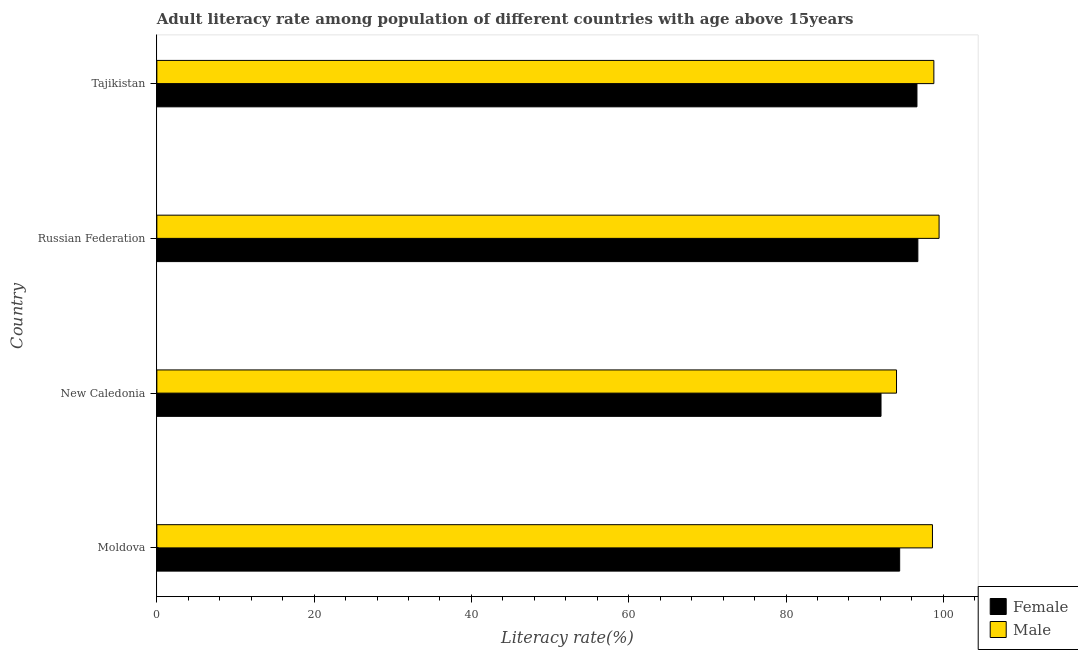How many groups of bars are there?
Provide a succinct answer. 4. Are the number of bars on each tick of the Y-axis equal?
Offer a terse response. Yes. How many bars are there on the 1st tick from the top?
Give a very brief answer. 2. What is the label of the 3rd group of bars from the top?
Offer a terse response. New Caledonia. In how many cases, is the number of bars for a given country not equal to the number of legend labels?
Keep it short and to the point. 0. What is the male adult literacy rate in New Caledonia?
Ensure brevity in your answer.  94.04. Across all countries, what is the maximum female adult literacy rate?
Your response must be concise. 96.76. Across all countries, what is the minimum male adult literacy rate?
Provide a short and direct response. 94.04. In which country was the female adult literacy rate maximum?
Offer a terse response. Russian Federation. In which country was the male adult literacy rate minimum?
Provide a succinct answer. New Caledonia. What is the total male adult literacy rate in the graph?
Your answer should be very brief. 390.91. What is the difference between the male adult literacy rate in Moldova and that in Russian Federation?
Offer a terse response. -0.84. What is the difference between the female adult literacy rate in Moldova and the male adult literacy rate in Tajikistan?
Keep it short and to the point. -4.35. What is the average male adult literacy rate per country?
Your answer should be compact. 97.73. What is the difference between the female adult literacy rate and male adult literacy rate in Russian Federation?
Ensure brevity in your answer.  -2.7. What is the ratio of the male adult literacy rate in Moldova to that in New Caledonia?
Keep it short and to the point. 1.05. What is the difference between the highest and the second highest male adult literacy rate?
Make the answer very short. 0.67. What is the difference between the highest and the lowest female adult literacy rate?
Your answer should be compact. 4.68. What does the 2nd bar from the top in Tajikistan represents?
Your answer should be compact. Female. What does the 2nd bar from the bottom in Moldova represents?
Provide a succinct answer. Male. How many bars are there?
Offer a terse response. 8. Are all the bars in the graph horizontal?
Keep it short and to the point. Yes. How many countries are there in the graph?
Offer a terse response. 4. What is the difference between two consecutive major ticks on the X-axis?
Ensure brevity in your answer.  20. Are the values on the major ticks of X-axis written in scientific E-notation?
Provide a succinct answer. No. Does the graph contain grids?
Offer a very short reply. No. Where does the legend appear in the graph?
Provide a succinct answer. Bottom right. How many legend labels are there?
Ensure brevity in your answer.  2. What is the title of the graph?
Your answer should be very brief. Adult literacy rate among population of different countries with age above 15years. Does "Transport services" appear as one of the legend labels in the graph?
Give a very brief answer. No. What is the label or title of the X-axis?
Ensure brevity in your answer.  Literacy rate(%). What is the Literacy rate(%) of Female in Moldova?
Your answer should be compact. 94.44. What is the Literacy rate(%) in Male in Moldova?
Offer a very short reply. 98.61. What is the Literacy rate(%) in Female in New Caledonia?
Your response must be concise. 92.07. What is the Literacy rate(%) of Male in New Caledonia?
Give a very brief answer. 94.04. What is the Literacy rate(%) in Female in Russian Federation?
Offer a very short reply. 96.76. What is the Literacy rate(%) of Male in Russian Federation?
Make the answer very short. 99.46. What is the Literacy rate(%) in Female in Tajikistan?
Give a very brief answer. 96.64. What is the Literacy rate(%) of Male in Tajikistan?
Your answer should be compact. 98.79. Across all countries, what is the maximum Literacy rate(%) of Female?
Keep it short and to the point. 96.76. Across all countries, what is the maximum Literacy rate(%) in Male?
Give a very brief answer. 99.46. Across all countries, what is the minimum Literacy rate(%) of Female?
Offer a very short reply. 92.07. Across all countries, what is the minimum Literacy rate(%) in Male?
Offer a very short reply. 94.04. What is the total Literacy rate(%) of Female in the graph?
Your answer should be very brief. 379.92. What is the total Literacy rate(%) of Male in the graph?
Your answer should be compact. 390.91. What is the difference between the Literacy rate(%) of Female in Moldova and that in New Caledonia?
Your answer should be compact. 2.37. What is the difference between the Literacy rate(%) of Male in Moldova and that in New Caledonia?
Offer a very short reply. 4.57. What is the difference between the Literacy rate(%) of Female in Moldova and that in Russian Federation?
Provide a succinct answer. -2.31. What is the difference between the Literacy rate(%) of Male in Moldova and that in Russian Federation?
Ensure brevity in your answer.  -0.84. What is the difference between the Literacy rate(%) in Female in Moldova and that in Tajikistan?
Ensure brevity in your answer.  -2.2. What is the difference between the Literacy rate(%) in Male in Moldova and that in Tajikistan?
Keep it short and to the point. -0.18. What is the difference between the Literacy rate(%) in Female in New Caledonia and that in Russian Federation?
Keep it short and to the point. -4.68. What is the difference between the Literacy rate(%) of Male in New Caledonia and that in Russian Federation?
Make the answer very short. -5.41. What is the difference between the Literacy rate(%) in Female in New Caledonia and that in Tajikistan?
Your answer should be very brief. -4.57. What is the difference between the Literacy rate(%) of Male in New Caledonia and that in Tajikistan?
Keep it short and to the point. -4.75. What is the difference between the Literacy rate(%) of Female in Russian Federation and that in Tajikistan?
Keep it short and to the point. 0.12. What is the difference between the Literacy rate(%) of Male in Russian Federation and that in Tajikistan?
Keep it short and to the point. 0.67. What is the difference between the Literacy rate(%) in Female in Moldova and the Literacy rate(%) in Male in New Caledonia?
Provide a succinct answer. 0.4. What is the difference between the Literacy rate(%) of Female in Moldova and the Literacy rate(%) of Male in Russian Federation?
Make the answer very short. -5.01. What is the difference between the Literacy rate(%) of Female in Moldova and the Literacy rate(%) of Male in Tajikistan?
Keep it short and to the point. -4.35. What is the difference between the Literacy rate(%) of Female in New Caledonia and the Literacy rate(%) of Male in Russian Federation?
Your response must be concise. -7.38. What is the difference between the Literacy rate(%) of Female in New Caledonia and the Literacy rate(%) of Male in Tajikistan?
Offer a very short reply. -6.72. What is the difference between the Literacy rate(%) in Female in Russian Federation and the Literacy rate(%) in Male in Tajikistan?
Keep it short and to the point. -2.03. What is the average Literacy rate(%) of Female per country?
Your response must be concise. 94.98. What is the average Literacy rate(%) in Male per country?
Ensure brevity in your answer.  97.73. What is the difference between the Literacy rate(%) in Female and Literacy rate(%) in Male in Moldova?
Your answer should be compact. -4.17. What is the difference between the Literacy rate(%) in Female and Literacy rate(%) in Male in New Caledonia?
Keep it short and to the point. -1.97. What is the difference between the Literacy rate(%) in Female and Literacy rate(%) in Male in Russian Federation?
Keep it short and to the point. -2.7. What is the difference between the Literacy rate(%) of Female and Literacy rate(%) of Male in Tajikistan?
Offer a terse response. -2.15. What is the ratio of the Literacy rate(%) in Female in Moldova to that in New Caledonia?
Provide a short and direct response. 1.03. What is the ratio of the Literacy rate(%) of Male in Moldova to that in New Caledonia?
Offer a very short reply. 1.05. What is the ratio of the Literacy rate(%) of Female in Moldova to that in Russian Federation?
Your response must be concise. 0.98. What is the ratio of the Literacy rate(%) of Male in Moldova to that in Russian Federation?
Offer a terse response. 0.99. What is the ratio of the Literacy rate(%) of Female in Moldova to that in Tajikistan?
Your answer should be compact. 0.98. What is the ratio of the Literacy rate(%) of Female in New Caledonia to that in Russian Federation?
Your response must be concise. 0.95. What is the ratio of the Literacy rate(%) in Male in New Caledonia to that in Russian Federation?
Give a very brief answer. 0.95. What is the ratio of the Literacy rate(%) of Female in New Caledonia to that in Tajikistan?
Offer a very short reply. 0.95. What is the ratio of the Literacy rate(%) of Male in New Caledonia to that in Tajikistan?
Your response must be concise. 0.95. What is the difference between the highest and the second highest Literacy rate(%) of Female?
Your response must be concise. 0.12. What is the difference between the highest and the second highest Literacy rate(%) of Male?
Provide a succinct answer. 0.67. What is the difference between the highest and the lowest Literacy rate(%) of Female?
Make the answer very short. 4.68. What is the difference between the highest and the lowest Literacy rate(%) of Male?
Your answer should be very brief. 5.41. 